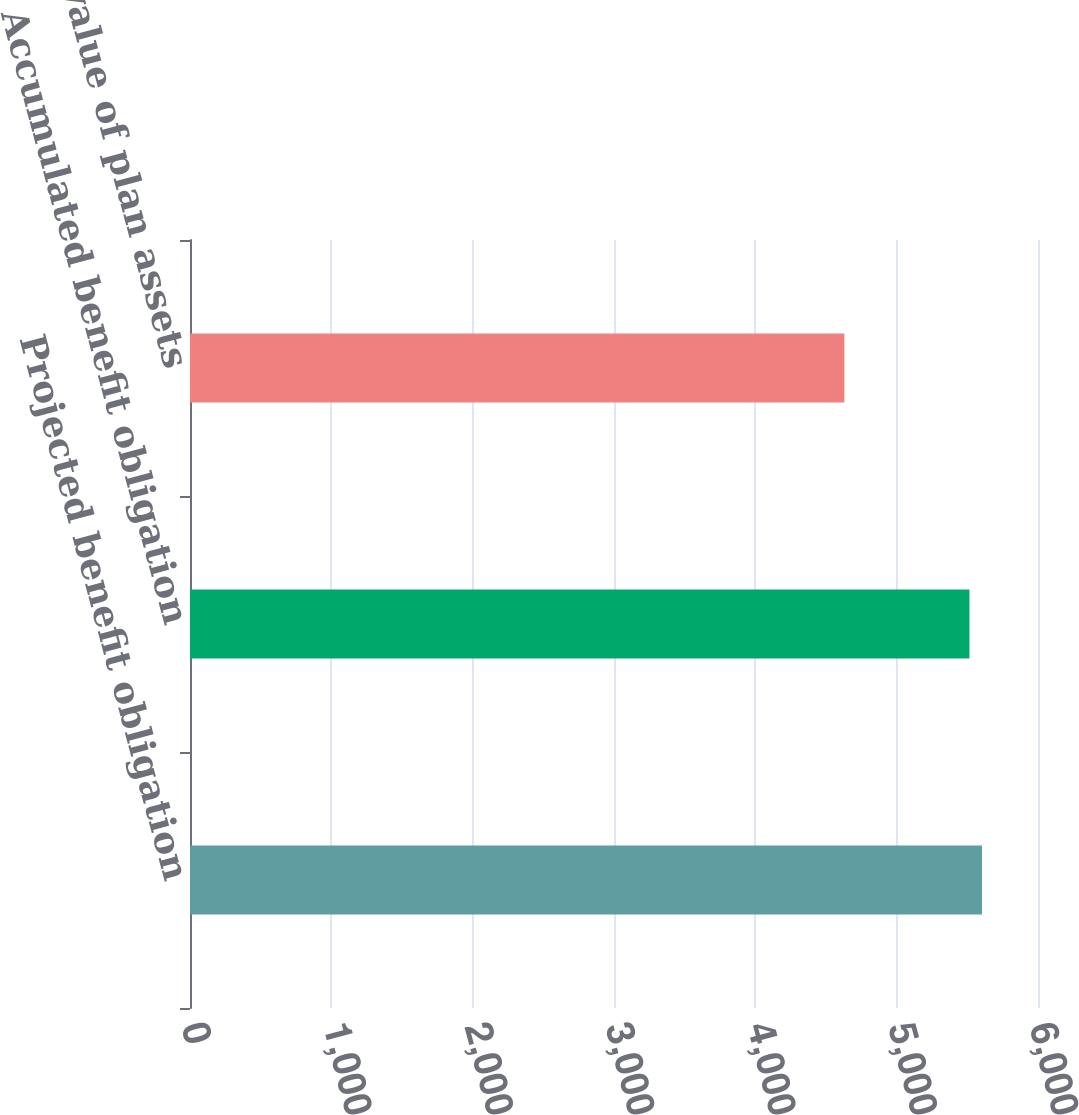Convert chart. <chart><loc_0><loc_0><loc_500><loc_500><bar_chart><fcel>Projected benefit obligation<fcel>Accumulated benefit obligation<fcel>Fair value of plan assets<nl><fcel>5603.6<fcel>5515<fcel>4630<nl></chart> 